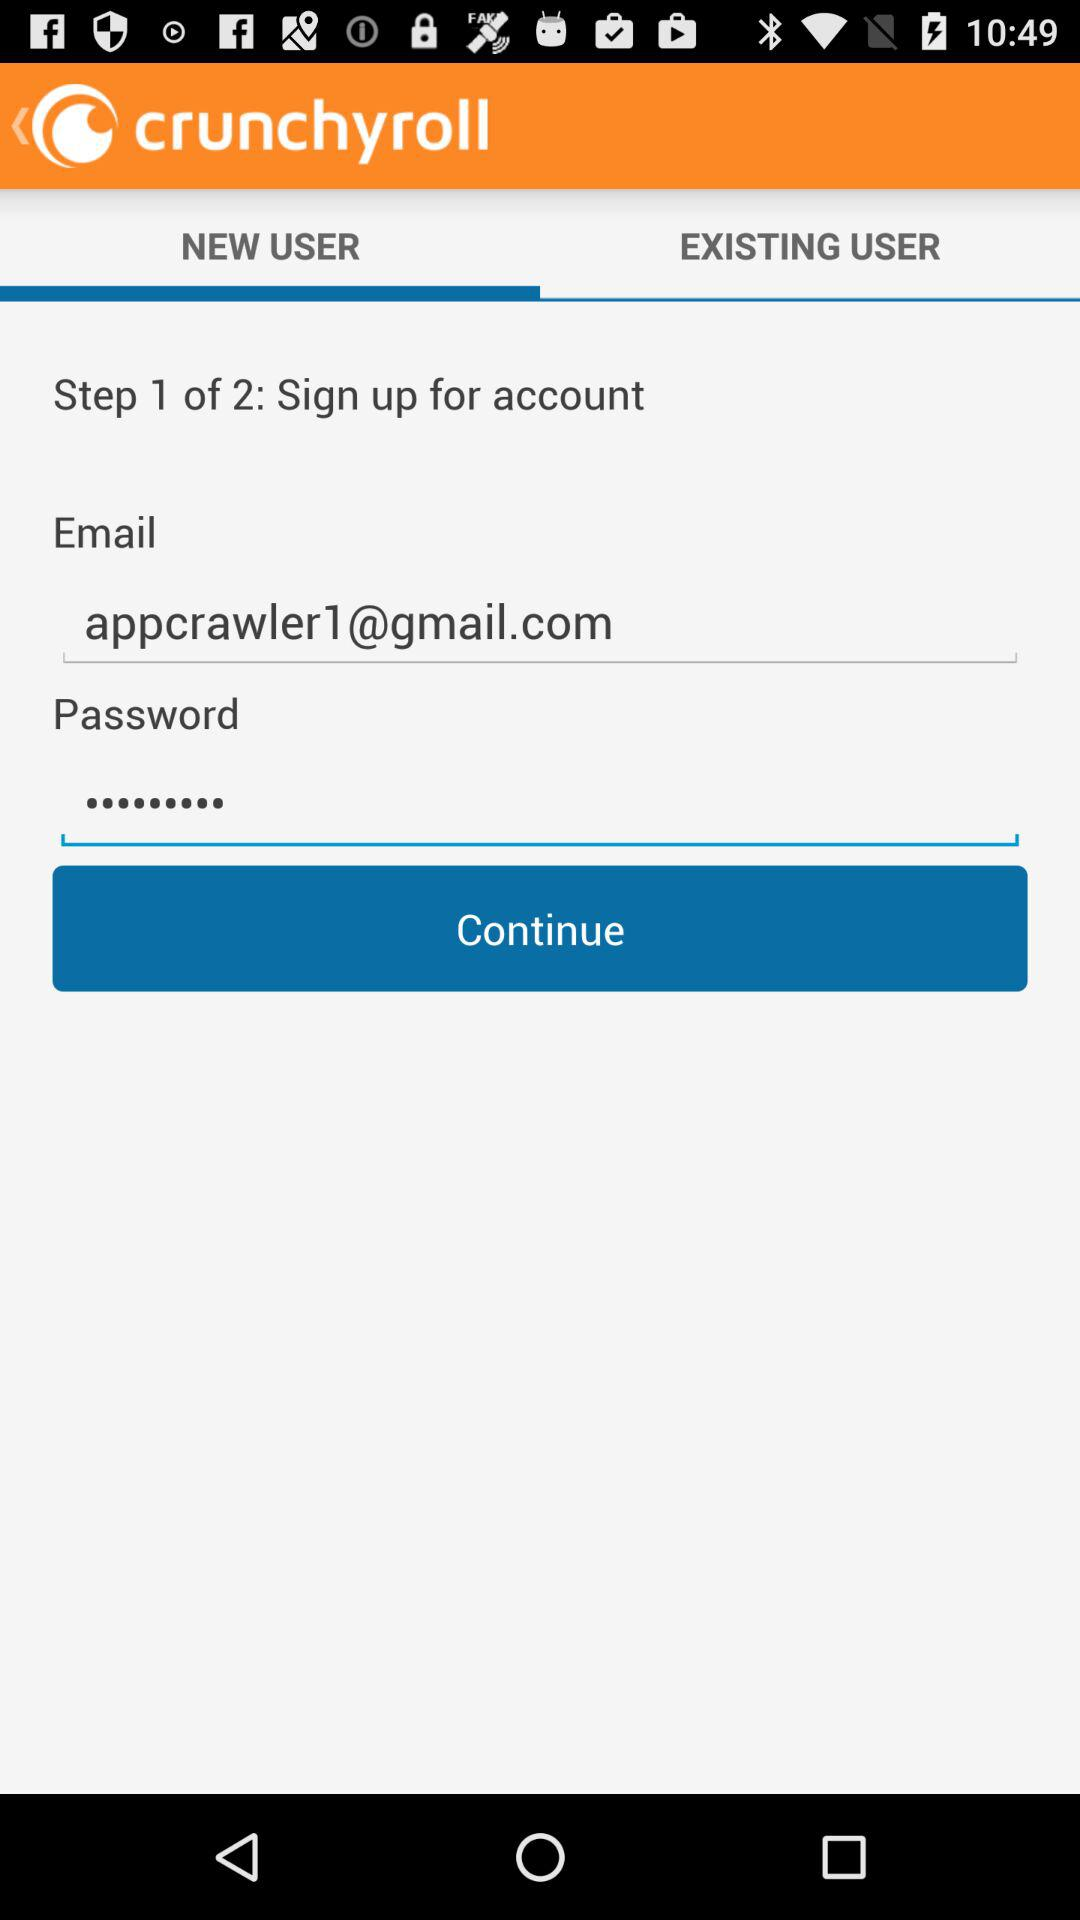Which "Step" are we at right now? You are at "Step" 1 right now. 